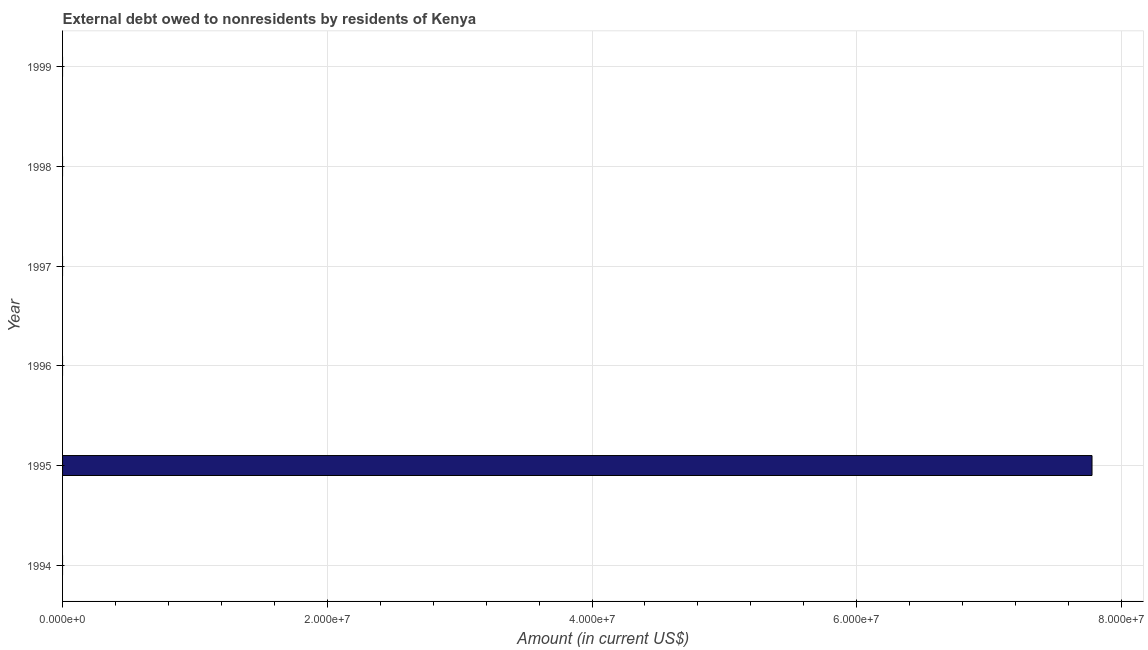Does the graph contain any zero values?
Make the answer very short. Yes. What is the title of the graph?
Ensure brevity in your answer.  External debt owed to nonresidents by residents of Kenya. What is the label or title of the X-axis?
Provide a succinct answer. Amount (in current US$). Across all years, what is the maximum debt?
Ensure brevity in your answer.  7.78e+07. Across all years, what is the minimum debt?
Offer a very short reply. 0. In which year was the debt maximum?
Keep it short and to the point. 1995. What is the sum of the debt?
Your answer should be very brief. 7.78e+07. What is the average debt per year?
Keep it short and to the point. 1.30e+07. What is the median debt?
Ensure brevity in your answer.  0. What is the difference between the highest and the lowest debt?
Make the answer very short. 7.78e+07. How many years are there in the graph?
Ensure brevity in your answer.  6. What is the Amount (in current US$) in 1995?
Offer a very short reply. 7.78e+07. What is the Amount (in current US$) of 1998?
Ensure brevity in your answer.  0. 